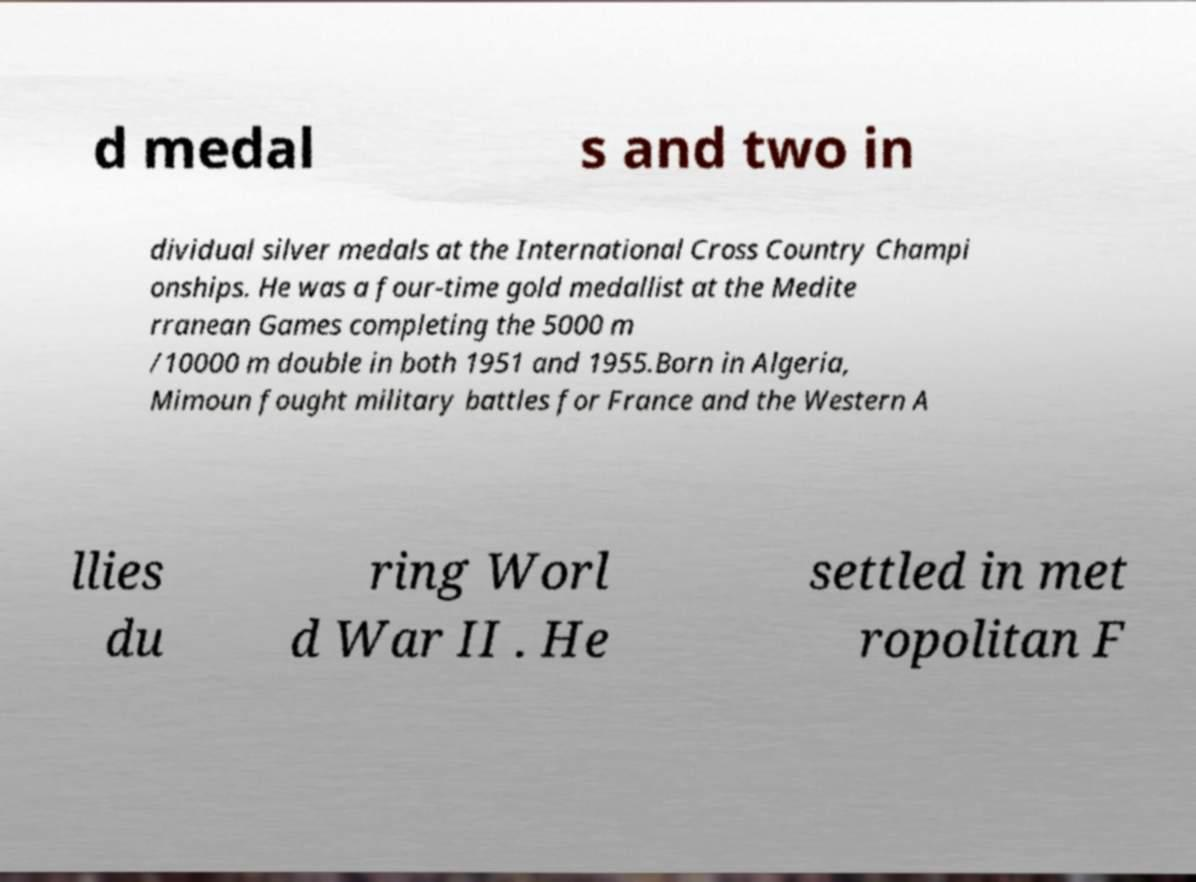There's text embedded in this image that I need extracted. Can you transcribe it verbatim? d medal s and two in dividual silver medals at the International Cross Country Champi onships. He was a four-time gold medallist at the Medite rranean Games completing the 5000 m /10000 m double in both 1951 and 1955.Born in Algeria, Mimoun fought military battles for France and the Western A llies du ring Worl d War II . He settled in met ropolitan F 